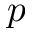<formula> <loc_0><loc_0><loc_500><loc_500>p</formula> 